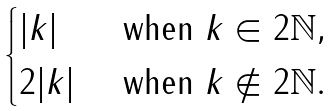<formula> <loc_0><loc_0><loc_500><loc_500>\begin{cases} | k | & \text { when } k \in 2 \mathbb { N } , \\ 2 | k | & \text { when } k \not \in 2 \mathbb { N } . \end{cases}</formula> 